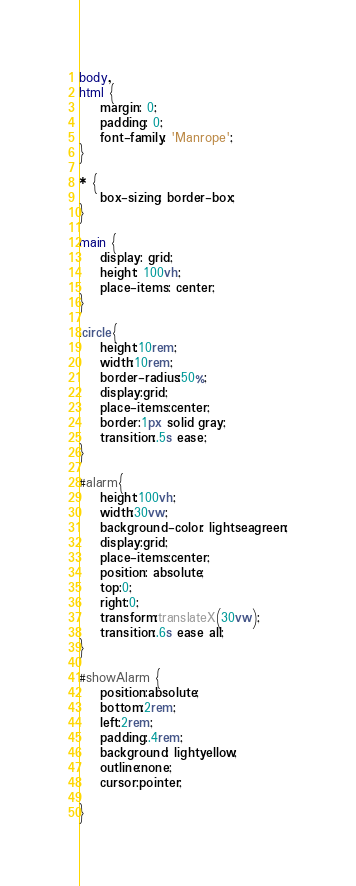Convert code to text. <code><loc_0><loc_0><loc_500><loc_500><_CSS_>
body,
html {
    margin: 0;
    padding: 0;
    font-family: 'Manrope';
}

* {
    box-sizing: border-box;
}

main {
    display: grid;
    height: 100vh;
    place-items: center;
}

.circle{
    height:10rem;
    width:10rem;
    border-radius:50%;
    display:grid;
    place-items:center;
    border:1px solid gray;
    transition:.5s ease;
}

#alarm{
    height:100vh;
    width:30vw;
    background-color: lightseagreen;
    display:grid;
    place-items:center;
    position: absolute;
    top:0;
    right:0;
    transform:translateX(30vw);
    transition:.6s ease all;
}

#showAlarm {
    position:absolute;
    bottom:2rem;
    left:2rem;
    padding:.4rem;
    background: lightyellow;
    outline:none;
    cursor:pointer;

}
</code> 